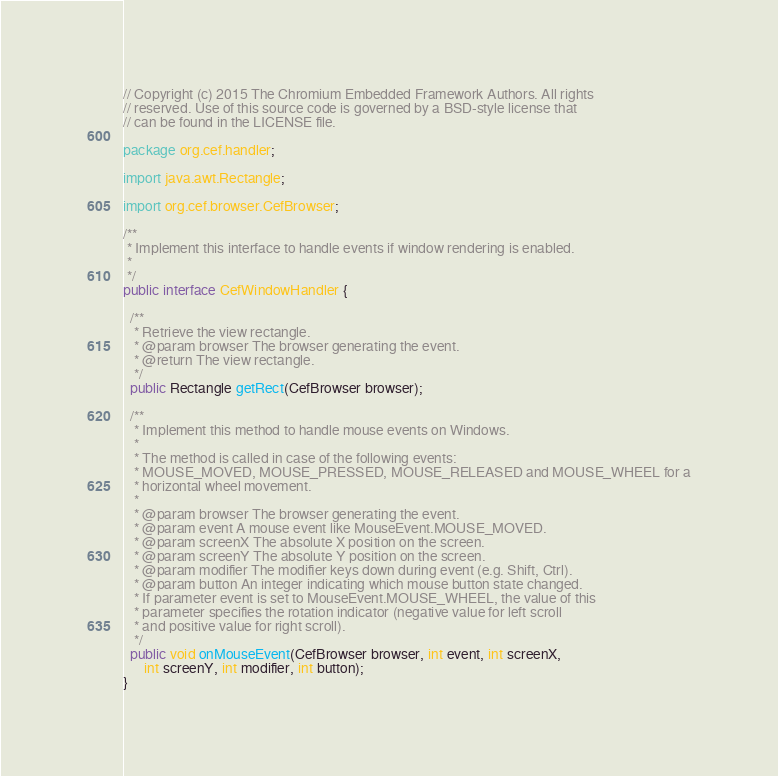Convert code to text. <code><loc_0><loc_0><loc_500><loc_500><_Java_>// Copyright (c) 2015 The Chromium Embedded Framework Authors. All rights
// reserved. Use of this source code is governed by a BSD-style license that
// can be found in the LICENSE file.

package org.cef.handler;

import java.awt.Rectangle;

import org.cef.browser.CefBrowser;

/**
 * Implement this interface to handle events if window rendering is enabled.
 *
 */
public interface CefWindowHandler {

  /**
   * Retrieve the view rectangle.
   * @param browser The browser generating the event.
   * @return The view rectangle.
   */
  public Rectangle getRect(CefBrowser browser);

  /**
   * Implement this method to handle mouse events on Windows.
   *
   * The method is called in case of the following events:
   * MOUSE_MOVED, MOUSE_PRESSED, MOUSE_RELEASED and MOUSE_WHEEL for a
   * horizontal wheel movement.
   *
   * @param browser The browser generating the event.
   * @param event A mouse event like MouseEvent.MOUSE_MOVED.
   * @param screenX The absolute X position on the screen.
   * @param screenY The absolute Y position on the screen.
   * @param modifier The modifier keys down during event (e.g. Shift, Ctrl).
   * @param button An integer indicating which mouse button state changed.
   * If parameter event is set to MouseEvent.MOUSE_WHEEL, the value of this
   * parameter specifies the rotation indicator (negative value for left scroll
   * and positive value for right scroll).
   */
  public void onMouseEvent(CefBrowser browser, int event, int screenX,
      int screenY, int modifier, int button);
}
</code> 